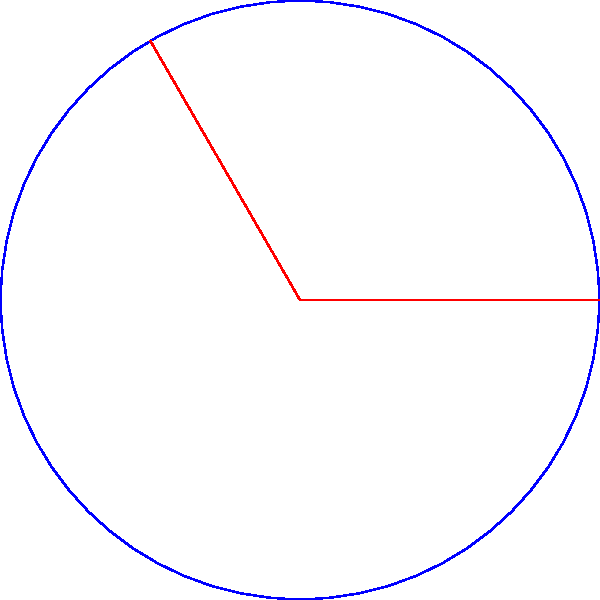In a Bollywood-themed amusement park, there's a circular dance floor with a radius of 3 cm. If a couple is performing a classic 120° twirl on this floor, what is the area of the sector they cover during their dance move? (Use $\pi = 3.14$ for calculations) Let's approach this step-by-step:

1) The formula for the area of a circular sector is:
   
   $$A = \frac{\theta}{360°} \cdot \pi r^2$$

   Where $\theta$ is the central angle in degrees, and $r$ is the radius.

2) We're given:
   - Radius (r) = 3 cm
   - Central angle ($\theta$) = 120°
   - $\pi = 3.14$

3) Let's substitute these values into our formula:

   $$A = \frac{120°}{360°} \cdot 3.14 \cdot 3^2$$

4) Simplify:
   $$A = \frac{1}{3} \cdot 3.14 \cdot 9$$

5) Calculate:
   $$A = 9.42 \text{ cm}^2$$

Therefore, the area of the sector covered by the couple during their 120° twirl is approximately 9.42 square centimeters.
Answer: 9.42 cm² 